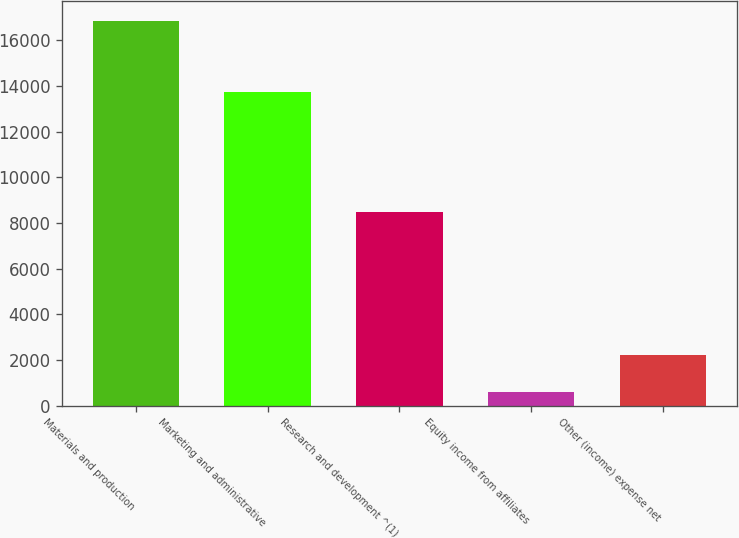Convert chart to OTSL. <chart><loc_0><loc_0><loc_500><loc_500><bar_chart><fcel>Materials and production<fcel>Marketing and administrative<fcel>Research and development ^(1)<fcel>Equity income from affiliates<fcel>Other (income) expense net<nl><fcel>16871<fcel>13733<fcel>8467<fcel>610<fcel>2236.1<nl></chart> 